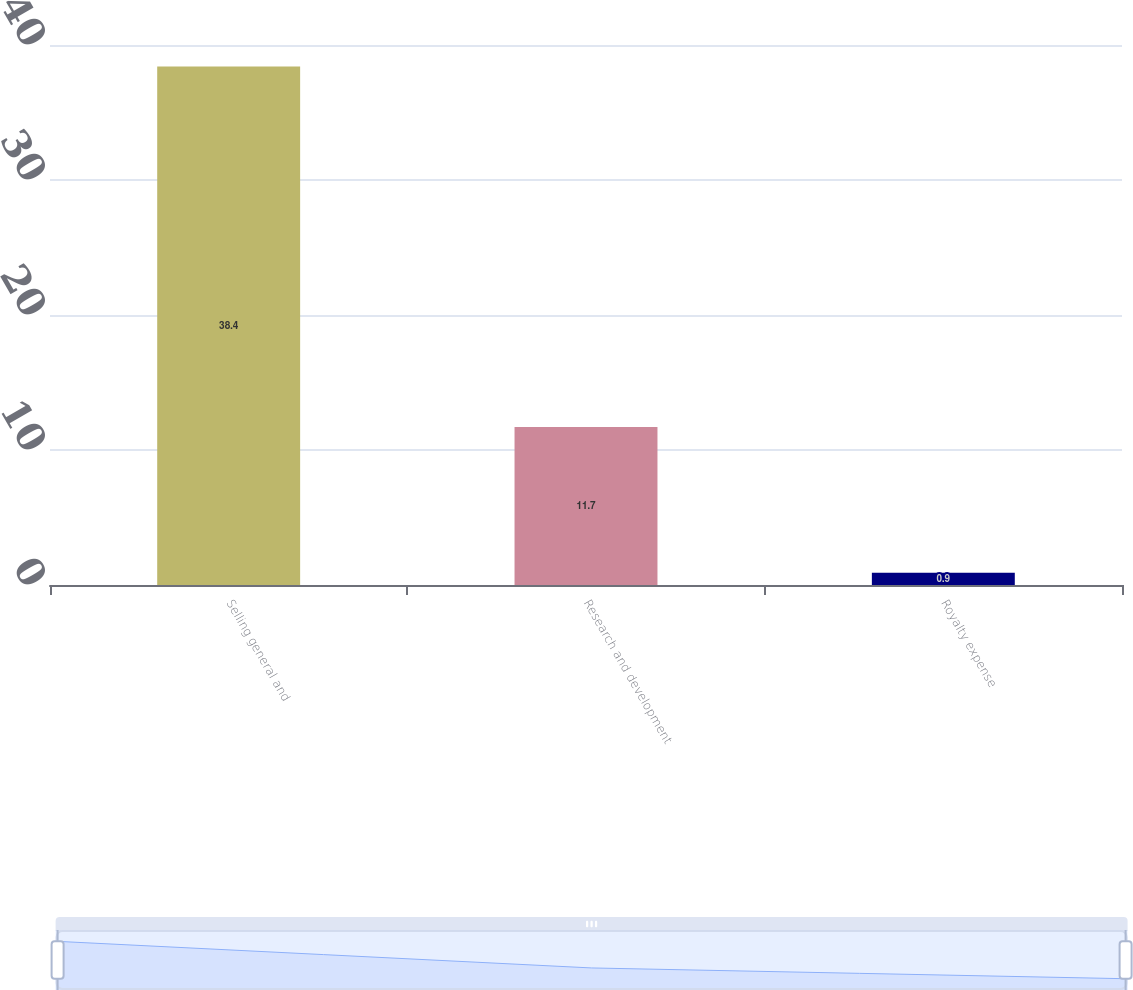Convert chart. <chart><loc_0><loc_0><loc_500><loc_500><bar_chart><fcel>Selling general and<fcel>Research and development<fcel>Royalty expense<nl><fcel>38.4<fcel>11.7<fcel>0.9<nl></chart> 